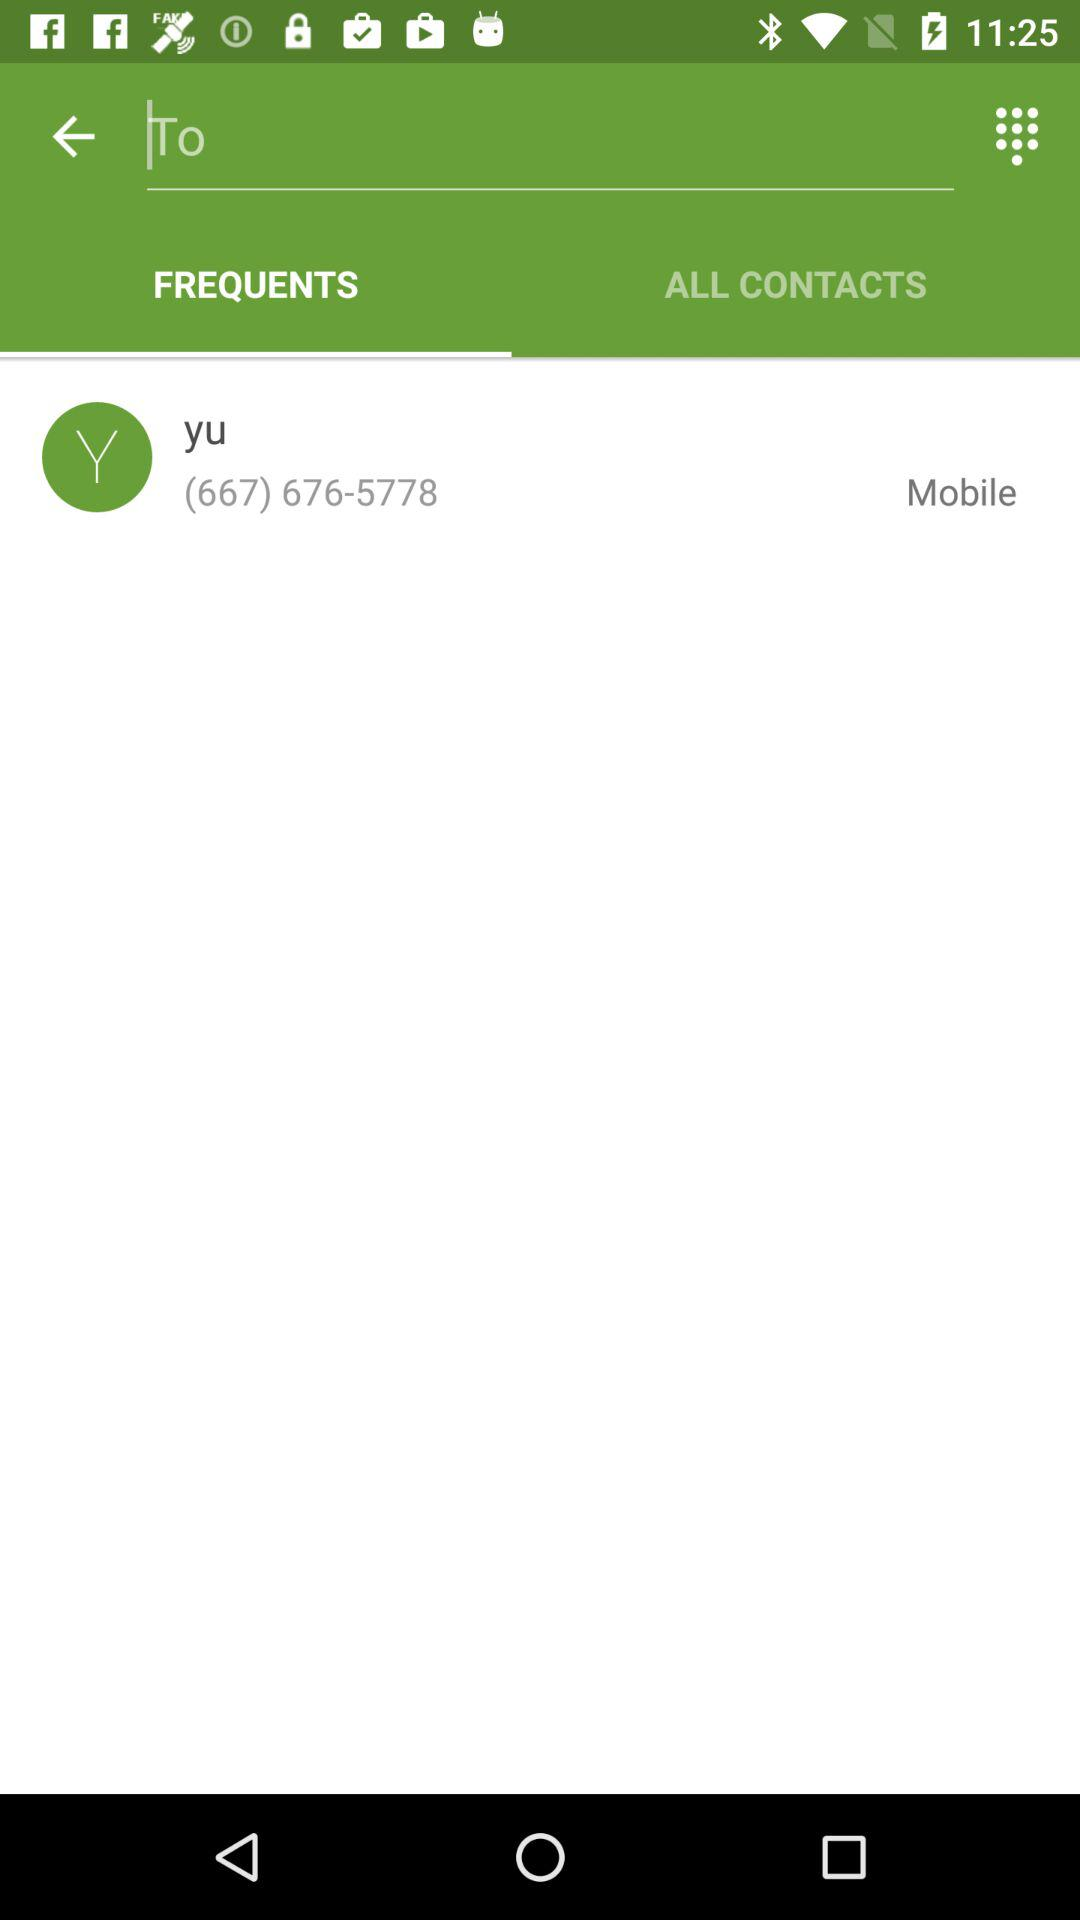How many digits are in the phone number?
Answer the question using a single word or phrase. 10 